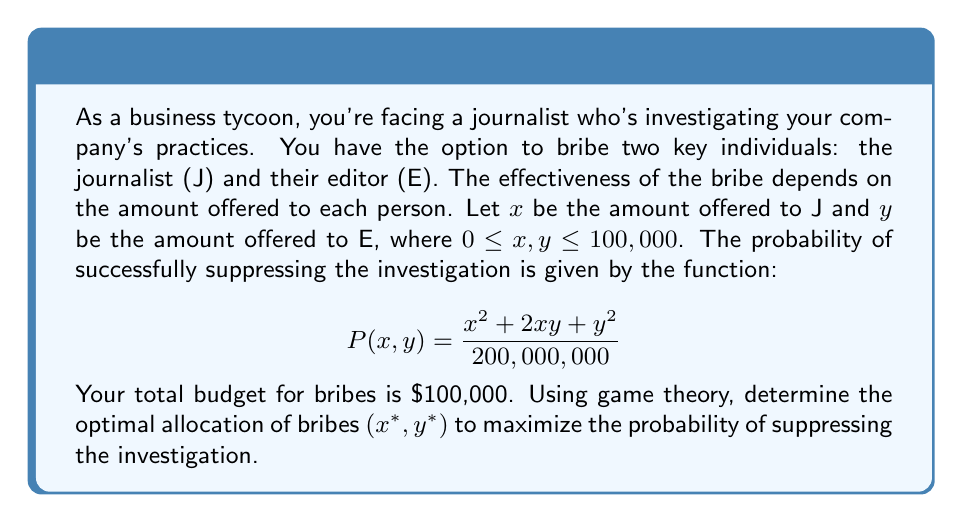Solve this math problem. To solve this problem, we'll use the method of Lagrange multipliers, which is a strategy for finding the local maxima and minima of a function subject to equality constraints.

1) First, let's define our objective function and constraint:
   Maximize: $P(x,y) = \frac{x^2 + 2xy + y^2}{200,000,000}$
   Subject to: $x + y = 100,000$ and $x,y \geq 0$

2) We form the Lagrangian function:
   $$L(x,y,\lambda) = \frac{x^2 + 2xy + y^2}{200,000,000} - \lambda(x + y - 100,000)$$

3) Now, we take partial derivatives and set them to zero:
   $$\frac{\partial L}{\partial x} = \frac{2x + 2y}{200,000,000} - \lambda = 0$$
   $$\frac{\partial L}{\partial y} = \frac{2x + 2y}{200,000,000} - \lambda = 0$$
   $$\frac{\partial L}{\partial \lambda} = -(x + y - 100,000) = 0$$

4) From the first two equations, we can see that:
   $$\frac{2x + 2y}{200,000,000} = \lambda$$
   This implies that $x = y$

5) Substituting this into the constraint equation:
   $x + x = 100,000$
   $2x = 100,000$
   $x = 50,000$

6) Therefore, $y$ must also equal 50,000

7) We should verify that this is indeed a maximum by checking the second derivatives, but in this case, it's clear that this is the global maximum due to the symmetry of the problem and the constraints.

8) The maximum probability of suppressing the investigation is:
   $$P(50000, 50000) = \frac{50000^2 + 2(50000)(50000) + 50000^2}{200,000,000} = 0.75$$
Answer: The optimal allocation of bribes is $x^* = 50,000$ to the journalist and $y^* = 50,000$ to the editor, resulting in a maximum probability of 0.75 of suppressing the investigation. 